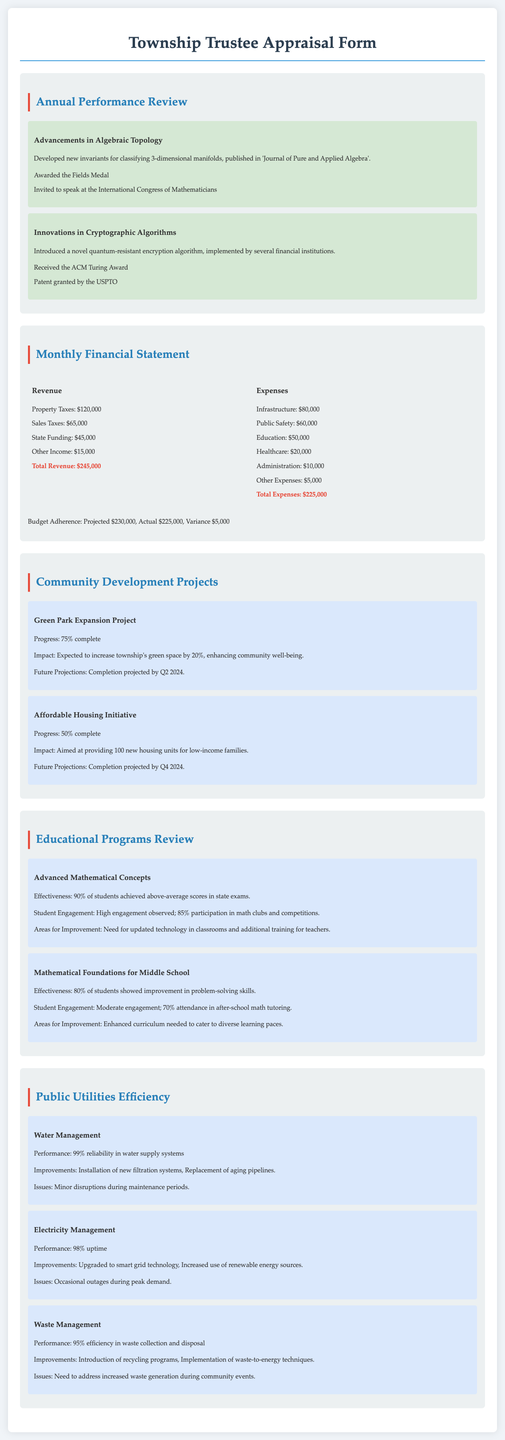What achievements were highlighted in the Annual Performance Review? The highlighted achievements were advancements in algebraic topology and innovations in cryptographic algorithms.
Answer: Advancements in Algebraic Topology, Innovations in Cryptographic Algorithms What is the total expense amount for the month? The total expense amount is provided in the Monthly Financial Statement, summing up all listed expenses.
Answer: $225,000 What is the progress percentage of the Green Park Expansion Project? The progress percentage is indicated under the Community Development Projects section regarding the Green Park Expansion Project.
Answer: 75% How many new housing units is the Affordable Housing Initiative aimed at providing? The document specifies that the Affordable Housing Initiative aims to provide 100 new housing units for low-income families.
Answer: 100 What percentage of students achieved above-average scores in the Advanced Mathematical Concepts program? The effectiveness of the program is given as 90%, indicating the percentage of students with above-average scores.
Answer: 90% What is the performance percentage of the water management system? The performance details for the water management system is provided, indicating its reliability percentage in the document.
Answer: 99% What award did the mathematician receive for innovations in cryptographic algorithms? The award received is mentioned in the context of the mathematician's contributions to cryptographic algorithms.
Answer: ACM Turing Award What is the budget variance stated in the Monthly Financial Statement? The budget variance is derived from the projected and actual budget amounts mentioned in the financial section.
Answer: $5,000 